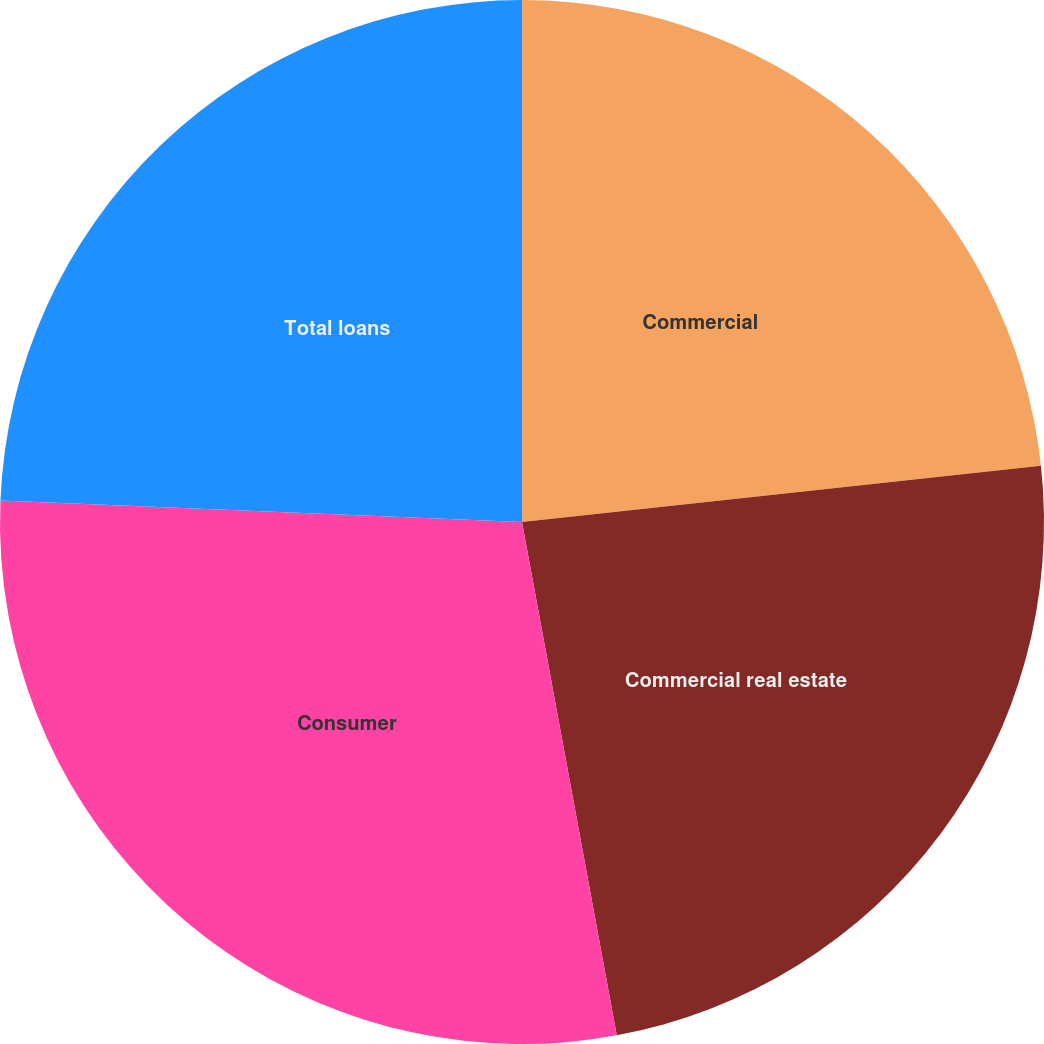Convert chart to OTSL. <chart><loc_0><loc_0><loc_500><loc_500><pie_chart><fcel>Commercial<fcel>Commercial real estate<fcel>Consumer<fcel>Total loans<nl><fcel>23.28%<fcel>23.81%<fcel>28.56%<fcel>24.34%<nl></chart> 